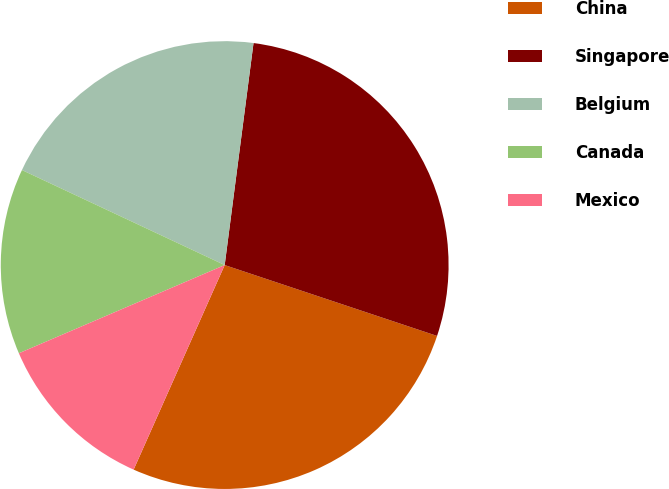Convert chart to OTSL. <chart><loc_0><loc_0><loc_500><loc_500><pie_chart><fcel>China<fcel>Singapore<fcel>Belgium<fcel>Canada<fcel>Mexico<nl><fcel>26.54%<fcel>28.07%<fcel>20.08%<fcel>13.42%<fcel>11.89%<nl></chart> 